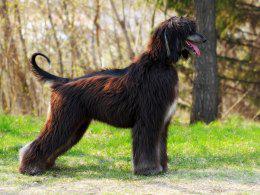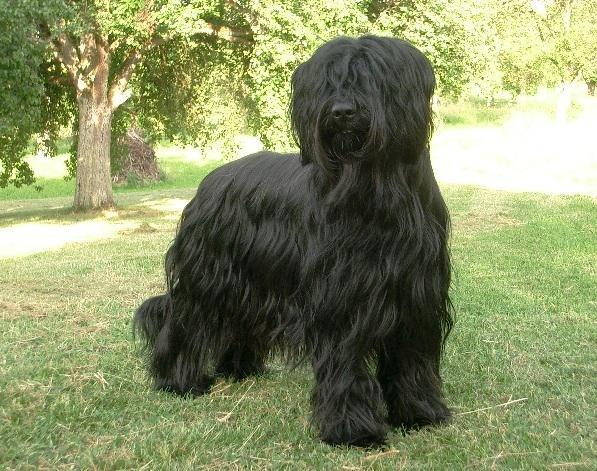The first image is the image on the left, the second image is the image on the right. For the images displayed, is the sentence "The left and right image contains the same number of dogs facing opposite directions." factually correct? Answer yes or no. No. The first image is the image on the left, the second image is the image on the right. Evaluate the accuracy of this statement regarding the images: "The dogs are oriented in opposite directions.". Is it true? Answer yes or no. No. 